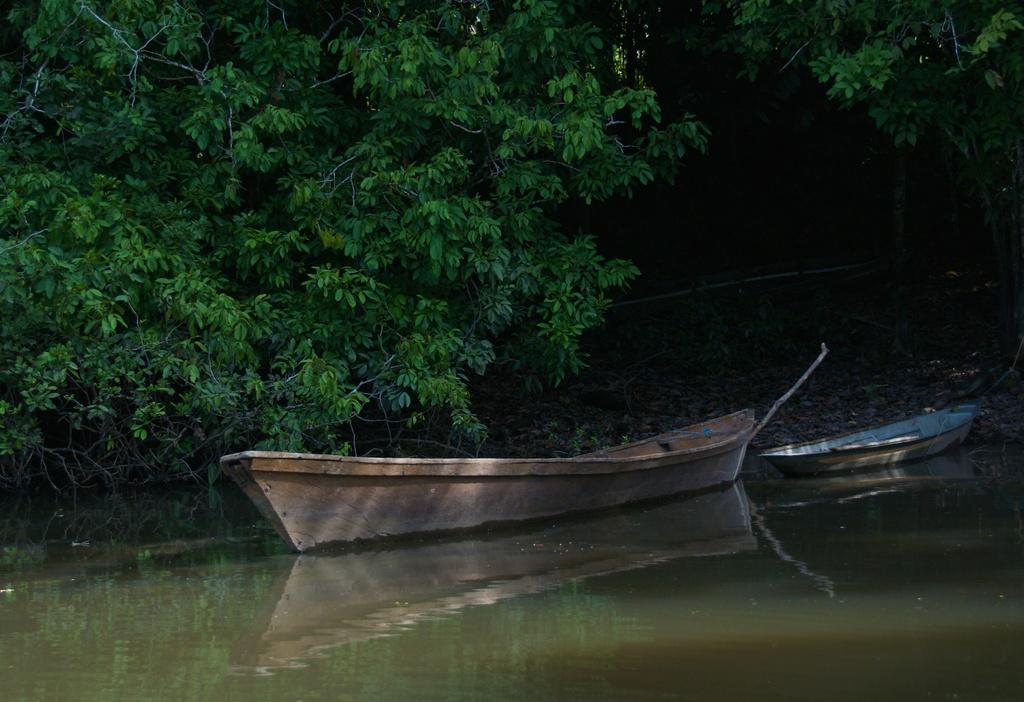What is the main subject of the image? The main subject of the image is a boat on the water. Are there any other boats in the image? Yes, there is another boat near the first boat. What can be seen in the background of the image? There are trees in the background of the image. Where is the group of books located in the image? There are no books present in the image; it features two boats on the water and trees in the background. 